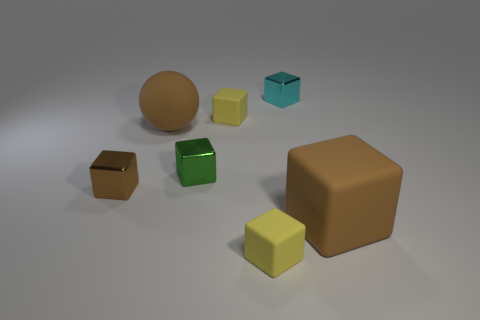Subtract all tiny cyan metallic cubes. How many cubes are left? 5 Subtract all green blocks. How many blocks are left? 5 Subtract all cubes. How many objects are left? 1 Add 1 blue cylinders. How many objects exist? 8 Subtract 2 blocks. How many blocks are left? 4 Subtract all blue spheres. How many yellow cubes are left? 2 Subtract all tiny metal objects. Subtract all big brown objects. How many objects are left? 2 Add 4 large brown rubber spheres. How many large brown rubber spheres are left? 5 Add 1 tiny yellow metallic objects. How many tiny yellow metallic objects exist? 1 Subtract 1 brown cubes. How many objects are left? 6 